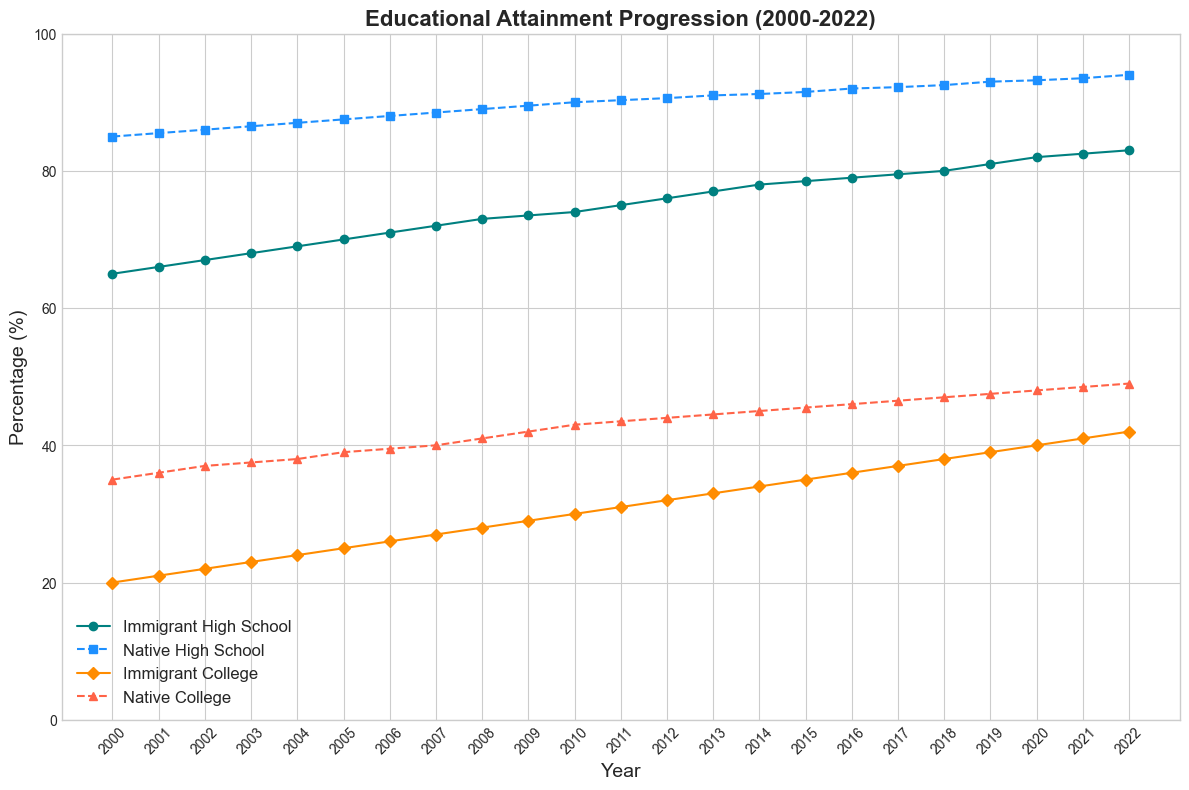What trend do you observe in the high school attainment rate for immigrants from 2000 to 2022? By examining the figure, you can see that the line representing immigrant high school attainment is consistently rising from 65% in 2000 to 83% in 2022, indicating a steady upward trend.
Answer: Steady upward trend In what year did both immigrant and native high school attainment rates reach 75% and 90% respectively? Looking at the figure, you can observe that the immigrant high school attainment rate reaches 75% and the native high school attainment rate is at 90.3% in 2011.
Answer: 2011 How does the college attainment rate of immigrants in 2022 compare visually to that of natives in the same year? Visually, the college attainment rate for immigrants in 2022 is marked by a dark orange line reaching 42%, while the native college rate is marked by a tomato-colored line reaching 49%, showing that the native population has a higher rate.
Answer: Native population has a higher rate Which group has experienced a greater increase in high school attainment from 2000 to 2022, immigrants or natives? Calculate the difference: for immigrants, it's 83% - 65% = 18%; for natives, it's 94% - 85% = 9%. Immigrants have experienced a greater increase.
Answer: Immigrants Are there any years where the college attainment rates for immigrants and natives are equal? By examining the figure, you can see that at no point do the lines for immigrant and native college attainment rates intersect or match exactly.
Answer: No What is the difference in college attainment rates between immigrants and natives in 2010? In 2010, the figure shows that the college attainment rate for immigrants is 30% and for natives is 43%. The difference is 43% - 30% = 13%.
Answer: 13% Compare the average high school attainment rates for immigrants and natives over the whole period from 2000 to 2022. Sum the high school attainment rates for each year for both groups and then divide by the number of years (23): Immigrant average = (65+66+...+83)/23, Native average = (85+85.5+...+94)/23. Immigrants' average is about 73.13%, and natives' average is approximately 89.5%.
Answer: Immigrants: 73.13%, Natives: 89.5% How does the rate of increase in college attainment for immigrants compare to natives from 2005 to 2020? Calculate the increase for both groups: Immigrants: 40% - 25% = 15%; Natives: 48% - 39% = 9%. Immigrants had a greater increase.
Answer: Immigrants had a greater increase By how many percentage points has the native high school attainment rate increased from 2002 to 2012? In 2002, the native high school rate is 86%, and in 2012 it is 90.6%. The increase is 90.6% - 86% = 4.6%.
Answer: 4.6% What is the visual difference in line styles between immigrant and native college attainment rates? The figure shows that the immigrant college attainment line uses solid lines, while the native college attainment line uses dashed lines, making it visually distinct.
Answer: Solid lines for immigrants, dashed lines for natives 